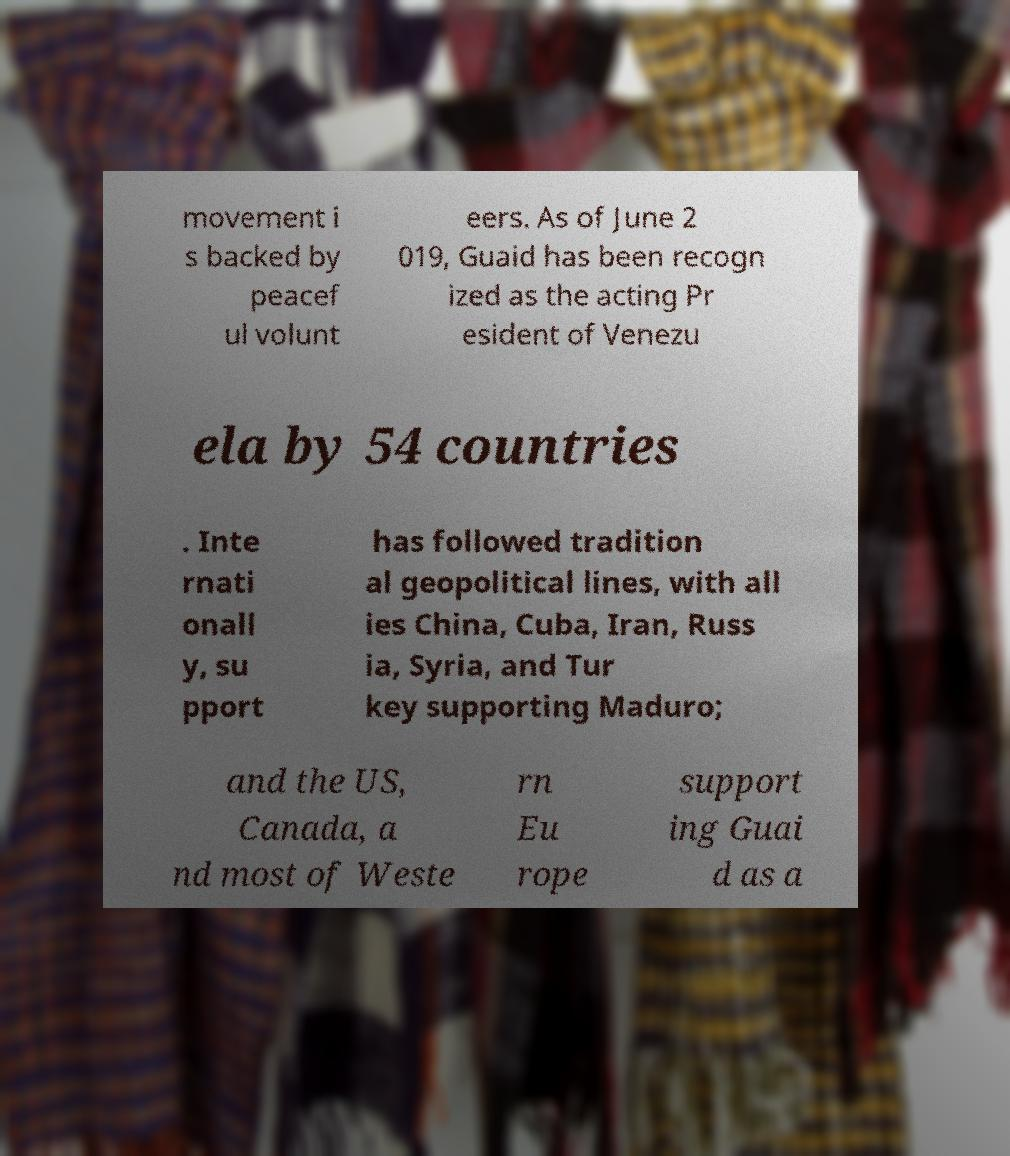Can you accurately transcribe the text from the provided image for me? movement i s backed by peacef ul volunt eers. As of June 2 019, Guaid has been recogn ized as the acting Pr esident of Venezu ela by 54 countries . Inte rnati onall y, su pport has followed tradition al geopolitical lines, with all ies China, Cuba, Iran, Russ ia, Syria, and Tur key supporting Maduro; and the US, Canada, a nd most of Weste rn Eu rope support ing Guai d as a 